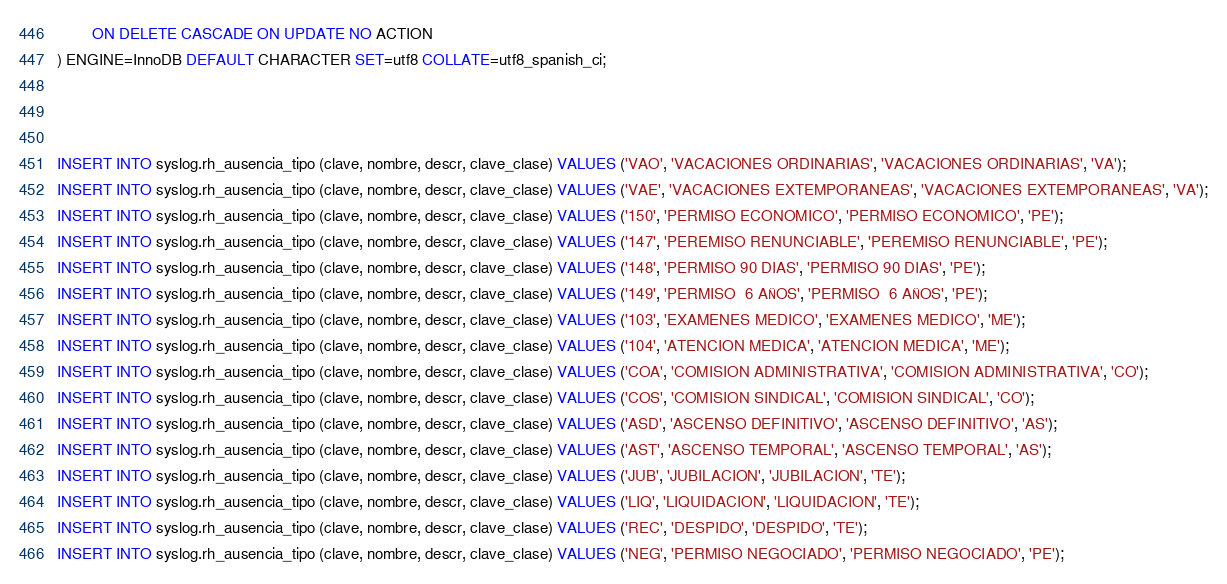Convert code to text. <code><loc_0><loc_0><loc_500><loc_500><_SQL_>		ON DELETE CASCADE ON UPDATE NO ACTION
) ENGINE=InnoDB DEFAULT CHARACTER SET=utf8 COLLATE=utf8_spanish_ci;



INSERT INTO syslog.rh_ausencia_tipo (clave, nombre, descr, clave_clase) VALUES ('VAO', 'VACACIONES ORDINARIAS', 'VACACIONES ORDINARIAS', 'VA');
INSERT INTO syslog.rh_ausencia_tipo (clave, nombre, descr, clave_clase) VALUES ('VAE', 'VACACIONES EXTEMPORANEAS', 'VACACIONES EXTEMPORANEAS', 'VA');
INSERT INTO syslog.rh_ausencia_tipo (clave, nombre, descr, clave_clase) VALUES ('150', 'PERMISO ECONOMICO', 'PERMISO ECONOMICO', 'PE');
INSERT INTO syslog.rh_ausencia_tipo (clave, nombre, descr, clave_clase) VALUES ('147', 'PEREMISO RENUNCIABLE', 'PEREMISO RENUNCIABLE', 'PE');
INSERT INTO syslog.rh_ausencia_tipo (clave, nombre, descr, clave_clase) VALUES ('148', 'PERMISO 90 DIAS', 'PERMISO 90 DIAS', 'PE');
INSERT INTO syslog.rh_ausencia_tipo (clave, nombre, descr, clave_clase) VALUES ('149', 'PERMISO  6 AÑOS', 'PERMISO  6 AÑOS', 'PE');
INSERT INTO syslog.rh_ausencia_tipo (clave, nombre, descr, clave_clase) VALUES ('103', 'EXAMENES MEDICO', 'EXAMENES MEDICO', 'ME');
INSERT INTO syslog.rh_ausencia_tipo (clave, nombre, descr, clave_clase) VALUES ('104', 'ATENCION MEDICA', 'ATENCION MEDICA', 'ME');
INSERT INTO syslog.rh_ausencia_tipo (clave, nombre, descr, clave_clase) VALUES ('COA', 'COMISION ADMINISTRATIVA', 'COMISION ADMINISTRATIVA', 'CO');
INSERT INTO syslog.rh_ausencia_tipo (clave, nombre, descr, clave_clase) VALUES ('COS', 'COMISION SINDICAL', 'COMISION SINDICAL', 'CO');
INSERT INTO syslog.rh_ausencia_tipo (clave, nombre, descr, clave_clase) VALUES ('ASD', 'ASCENSO DEFINITIVO', 'ASCENSO DEFINITIVO', 'AS');
INSERT INTO syslog.rh_ausencia_tipo (clave, nombre, descr, clave_clase) VALUES ('AST', 'ASCENSO TEMPORAL', 'ASCENSO TEMPORAL', 'AS');
INSERT INTO syslog.rh_ausencia_tipo (clave, nombre, descr, clave_clase) VALUES ('JUB', 'JUBILACION', 'JUBILACION', 'TE');
INSERT INTO syslog.rh_ausencia_tipo (clave, nombre, descr, clave_clase) VALUES ('LIQ', 'LIQUIDACION', 'LIQUIDACION', 'TE');
INSERT INTO syslog.rh_ausencia_tipo (clave, nombre, descr, clave_clase) VALUES ('REC', 'DESPIDO', 'DESPIDO', 'TE');
INSERT INTO syslog.rh_ausencia_tipo (clave, nombre, descr, clave_clase) VALUES ('NEG', 'PERMISO NEGOCIADO', 'PERMISO NEGOCIADO', 'PE');</code> 